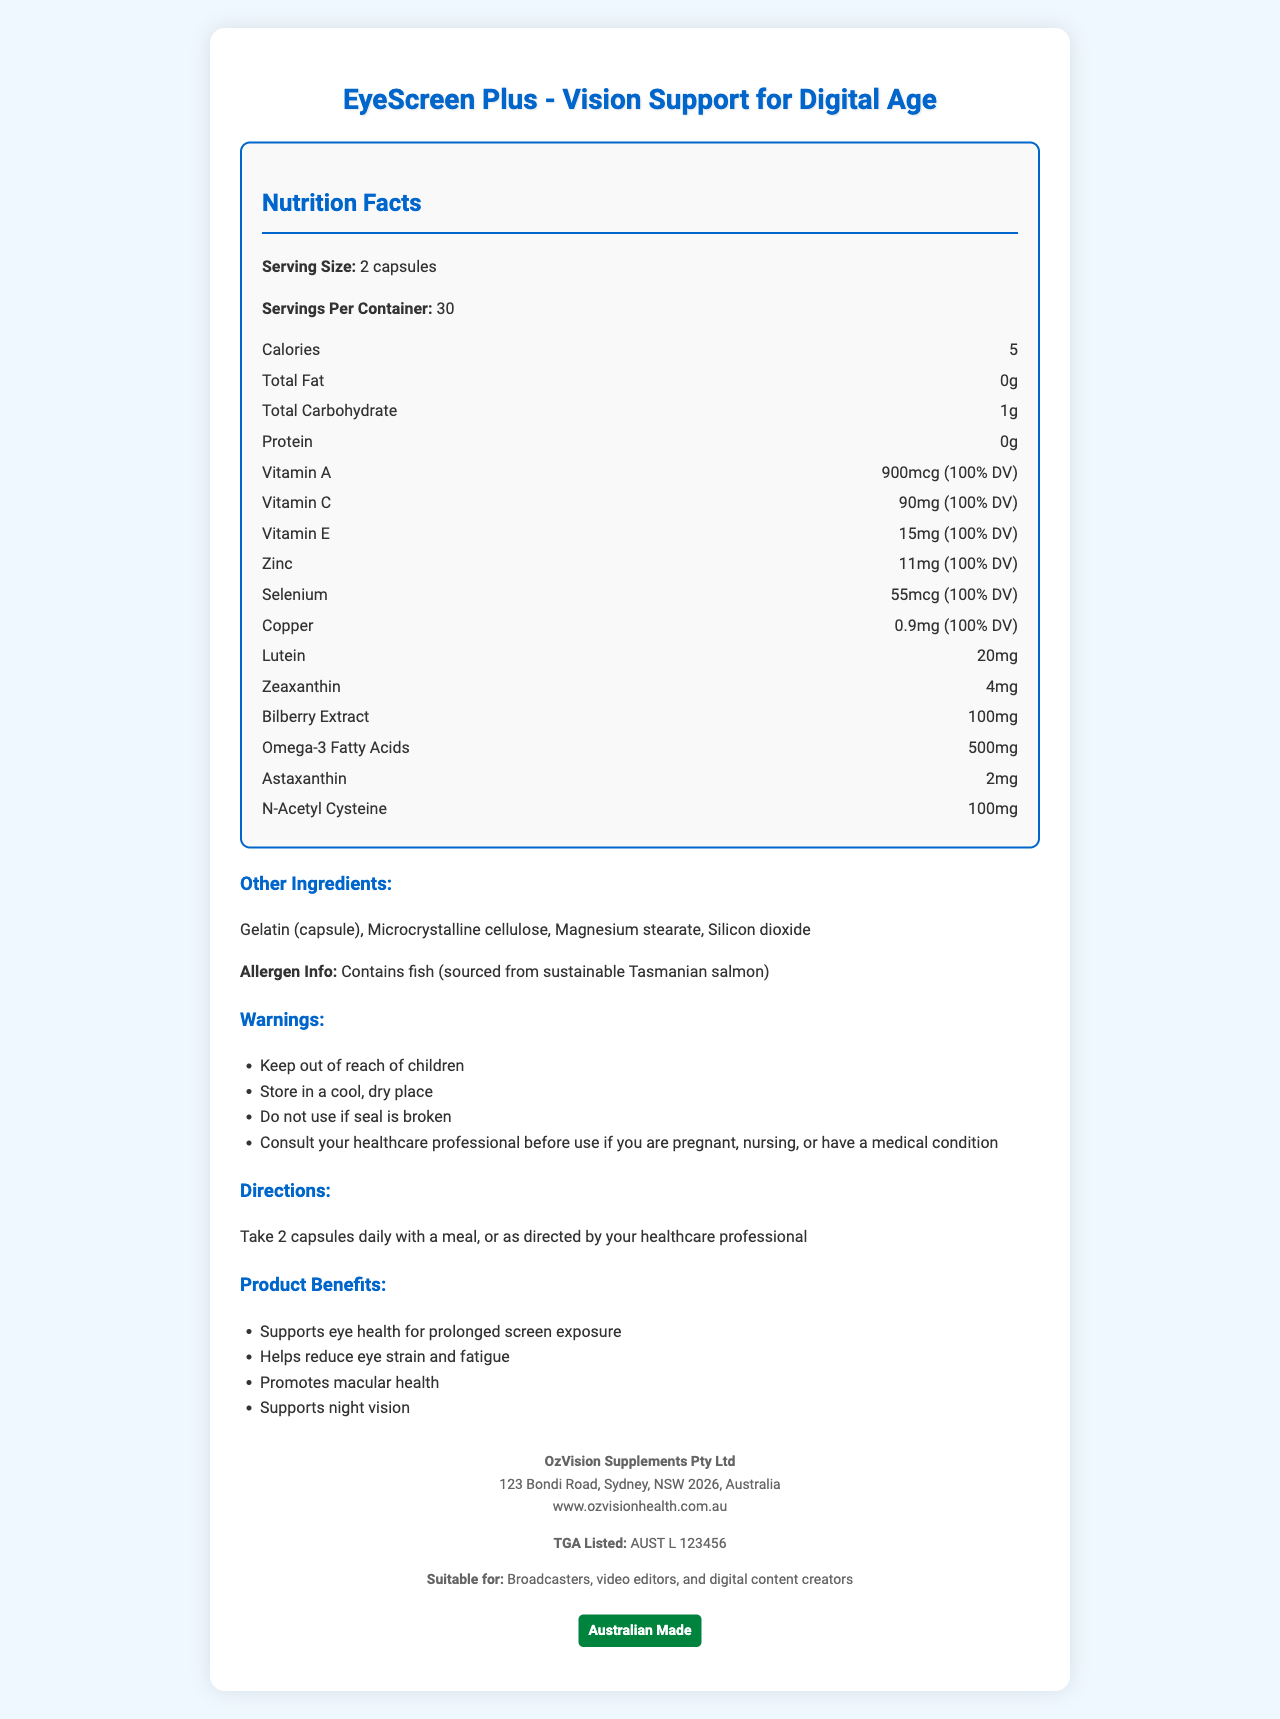How many capsules are suggested per serving? The serving size mentioned in the document is "2 capsules".
Answer: 2 capsules What is the address of the manufacturer? The manufacturer's address is listed at the bottom of the document.
Answer: 123 Bondi Road, Sydney, NSW 2026, Australia How many milligrams of Vitamin C are in one serving? The document states that one serving contains 90mg of Vitamin C.
Answer: 90mg Does the supplement contain any Omega-3 fatty acids? The document mentions that each serving contains 500mg of Omega-3 fatty acids.
Answer: Yes What other ingredient is listed besides Gelatin (capsule)? Among other ingredients listed besides Gelatin (capsule), Microcrystalline cellulose is mentioned.
Answer: Microcrystalline cellulose Which vitamin has a 900mcg dosage per serving? 
A. Vitamin A 
B. Vitamin C 
C. Vitamin E The document notes that each serving contains 900mcg of Vitamin A.
Answer: A What is the total carbohydrate content per serving?
I. 0g 
II. 1g 
III. 2g The document shows that the total carbohydrate content per serving is 1g.
Answer: II Is this product suitable for video editors? The product is explicitly stated to be suitable for broadcasters, video editors, and digital content creators.
Answer: Yes Is the product allergen-free? The product contains fish, as stated in the allergen information section.
Answer: No What are the product benefits listed in the document? The document lists these as the product benefits.
Answer: Supports eye health for prolonged screen exposure, Helps reduce eye strain and fatigue, Promotes macular health, Supports night vision Summarize the main idea of the document. The document presents comprehensive information about the EyeScreen Plus supplement, emphasizing ingredients, benefits, and consumption guidelines, and targeting individuals involved in extensive screen usage.
Answer: The document provides detailed information about EyeScreen Plus, a vitamin supplement designed to support eye health for individuals exposed to prolonged screen use. It includes nutritional facts, ingredients, directions for use, product benefits, and manufacturer details. The product is suitable for broadcasters, video editors, and digital content creators, and it is Australian Made and TGA listed. How many calories are in one serving of the product? The document states that there are 5 calories per serving.
Answer: 5 calories Can children consume EyeScreen Plus? While the document does mention "Keep out of reach of children" in the warnings section, it does not explicitly state whether children can or cannot use the product.
Answer: Not enough information 